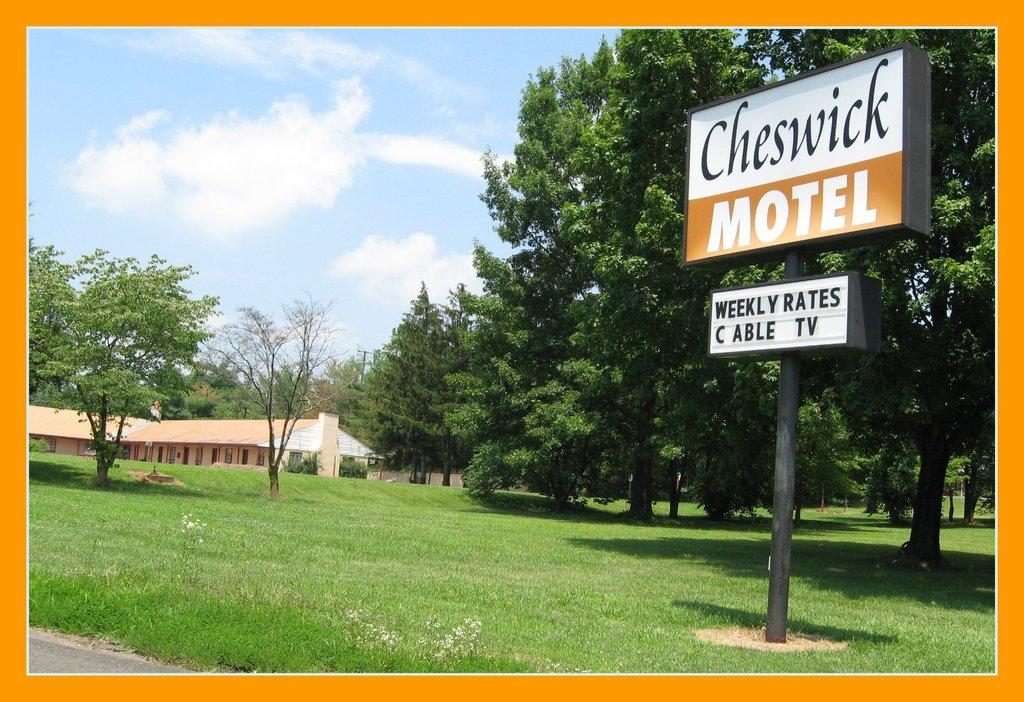What type of vegetation is present in the image? There is grass in the image. What structures can be seen in the image? There is a pole, a board, a building, and a road in the image. What natural elements are present in the image? There are trees in the image. What is the condition of the sky in the image? The sky is cloudy and pale blue in the image. What is the color of the border around the image? The border around the image is orange. How many sheep are visible in the image? There are no sheep present in the image. What type of ghost can be seen interacting with the trees in the image? There are no ghosts present in the image. 